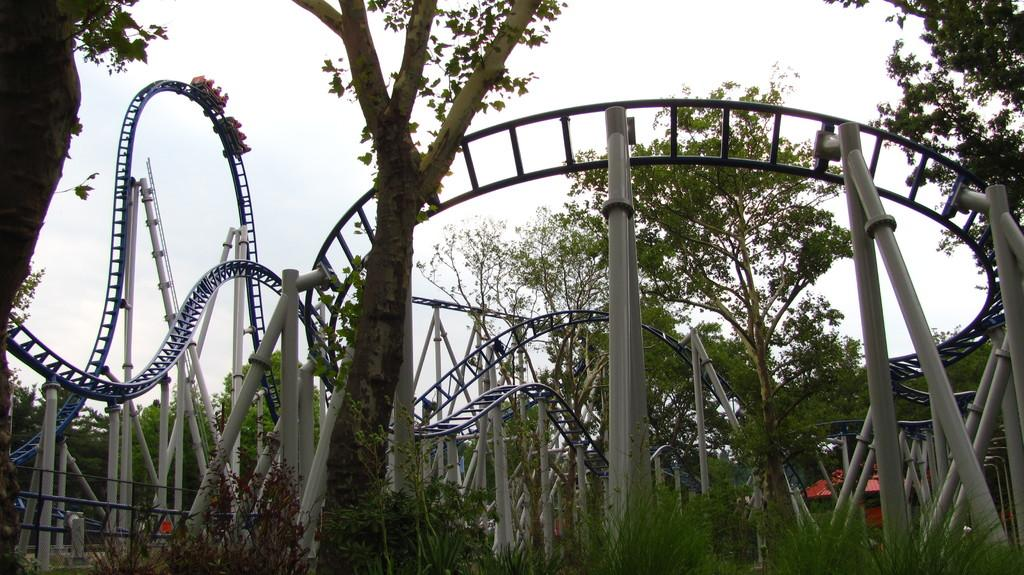What is the main subject of the picture? The main subject of the picture is a roller coaster. What structures can be seen in the picture besides the roller coaster? There are pillars in the picture. What type of natural elements are present in the picture? There are trees in the picture. What can be seen in the background of the picture? The sky is visible in the background of the picture. What type of lace can be seen on the roller coaster in the picture? There is no lace present on the roller coaster in the picture. Can you provide an example of a similar roller coaster to the one in the picture? The provided image is the only reference for the roller coaster, so it is not possible to provide an example of a similar one. 